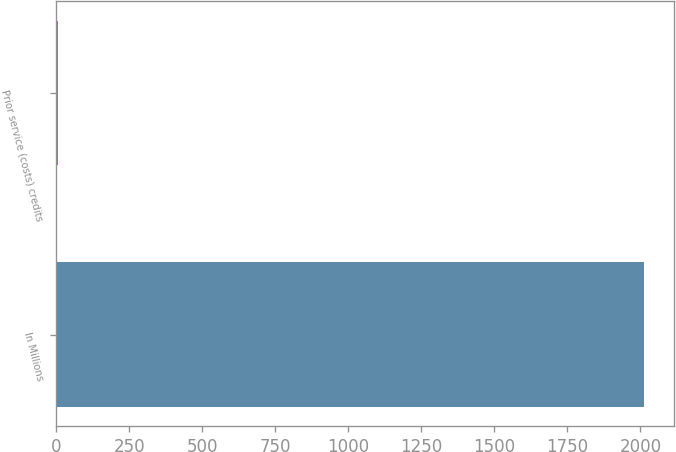Convert chart to OTSL. <chart><loc_0><loc_0><loc_500><loc_500><bar_chart><fcel>In Millions<fcel>Prior service (costs) credits<nl><fcel>2014<fcel>4<nl></chart> 